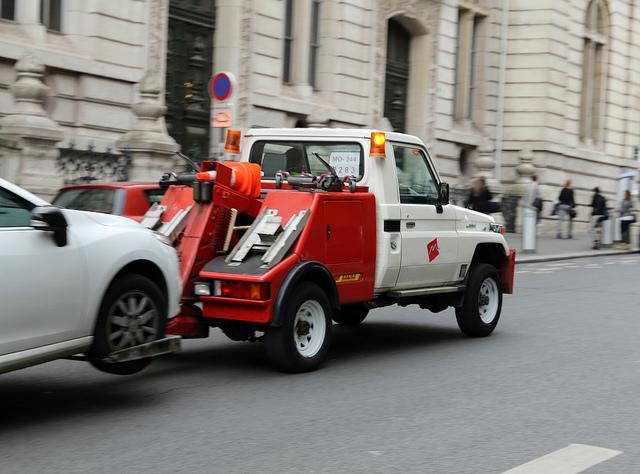What type of truck is being pictured in this image? Please explain your reasoning. tow truck. There is a car behind being towed 